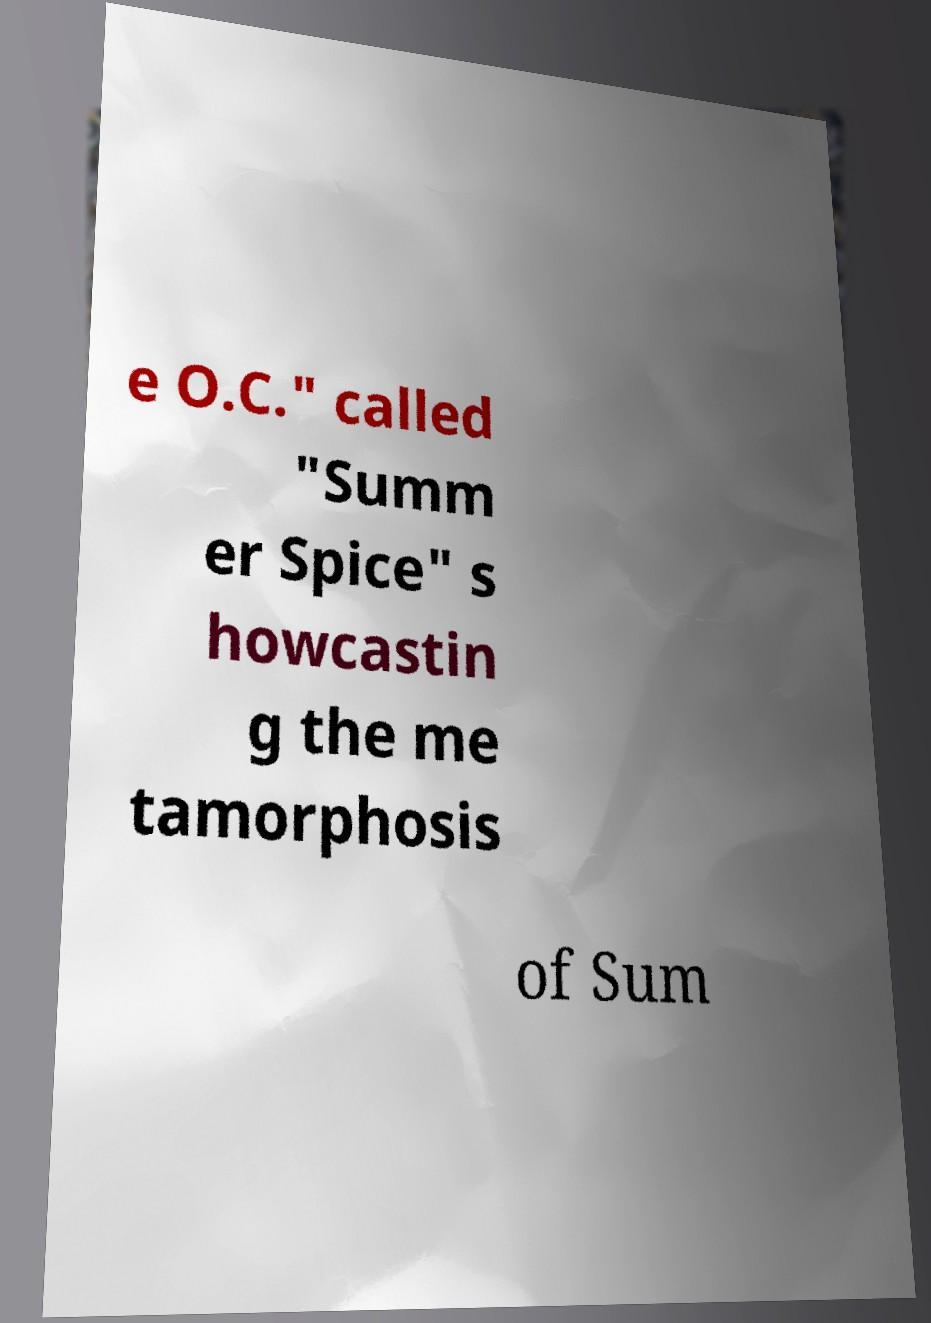What messages or text are displayed in this image? I need them in a readable, typed format. e O.C." called "Summ er Spice" s howcastin g the me tamorphosis of Sum 